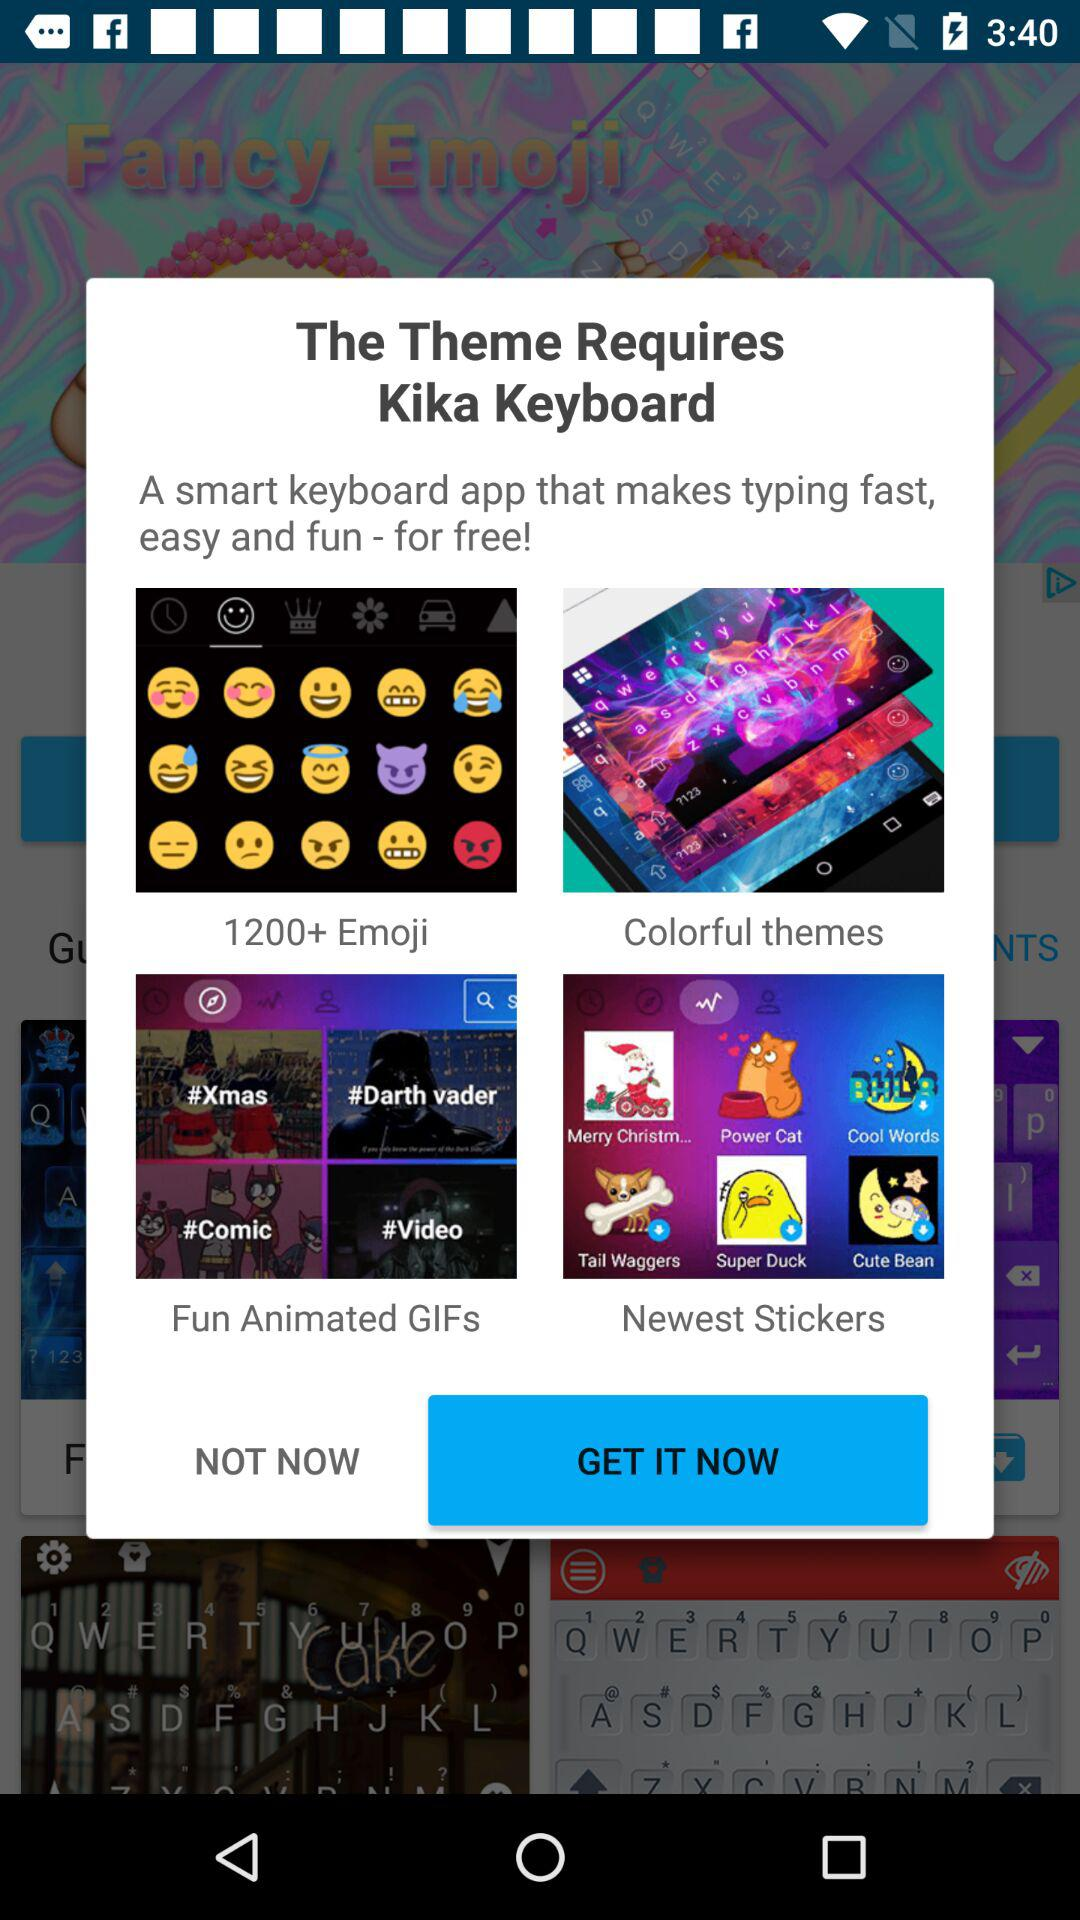What is the name of the application that is required by the theme? The name of the application is "Kika Keyboard". 